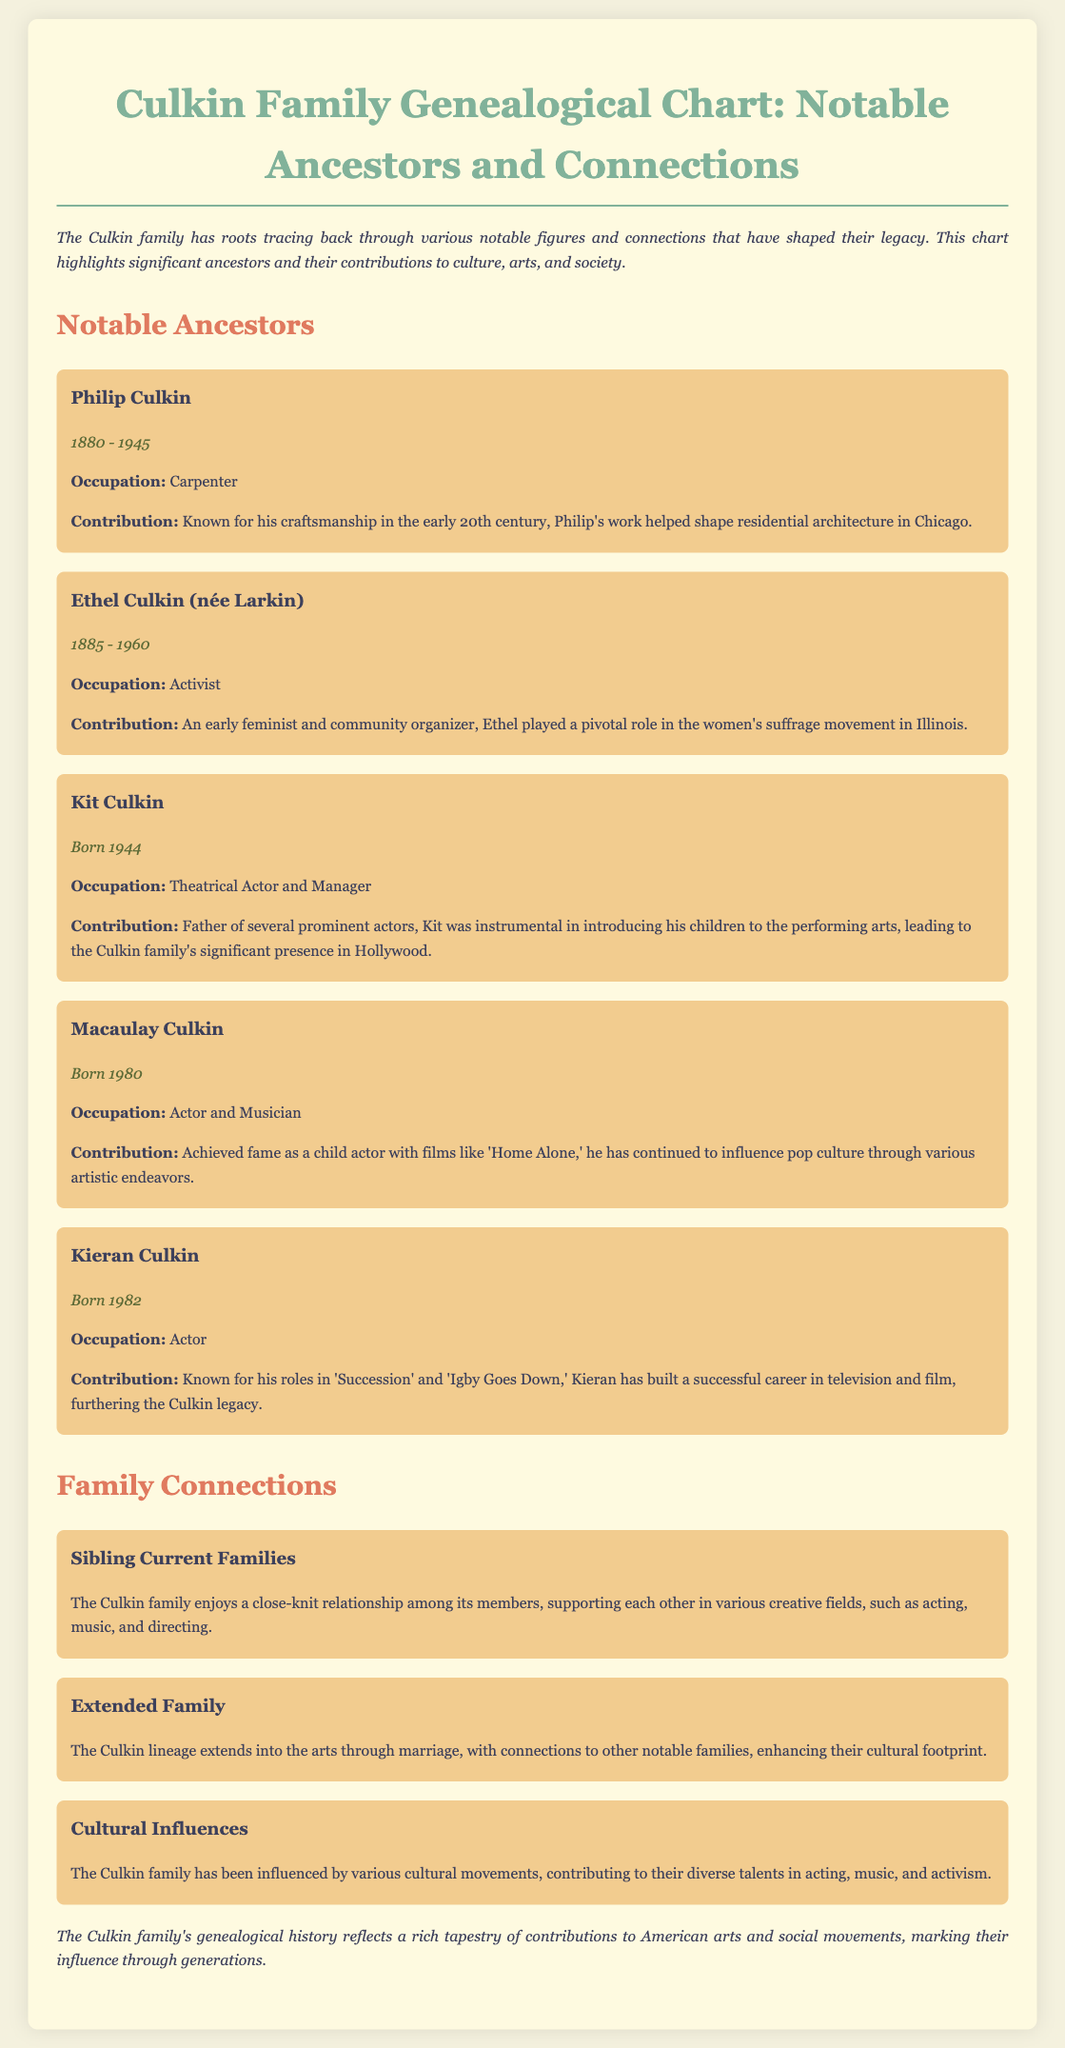what years did Philip Culkin live? The document states Philip Culkin was born in 1880 and died in 1945.
Answer: 1880 - 1945 who is Ethel Culkin's maiden name? The document mentions Ethel Culkin was née Larkin.
Answer: Larkin what is Kit Culkin's occupation? The document lists Kit Culkin as a Theatrical Actor and Manager.
Answer: Theatrical Actor and Manager how is Macaulay Culkin best known? The document states he achieved fame as a child actor with films like 'Home Alone.'
Answer: Child actor what contributions did Ethel Culkin make? The document describes her as playing a pivotal role in the women's suffrage movement in Illinois.
Answer: Women's suffrage movement what is a notable connection within the Culkin family? The document indicates that the family supports each other in various creative fields such as acting, music, and directing.
Answer: Close-knit relationship how does Kieran Culkin contribute to the Culkin legacy? He has built a successful career in television and film.
Answer: Successful career which cultural movement influenced the Culkin family? The document states that they have been influenced by various cultural movements.
Answer: Cultural movements 